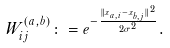Convert formula to latex. <formula><loc_0><loc_0><loc_500><loc_500>W ^ { ( a , b ) } _ { i j } \colon = e ^ { - \frac { \| x _ { a , i } - x _ { b , j } \| ^ { 2 } } { 2 \sigma ^ { 2 } } } .</formula> 